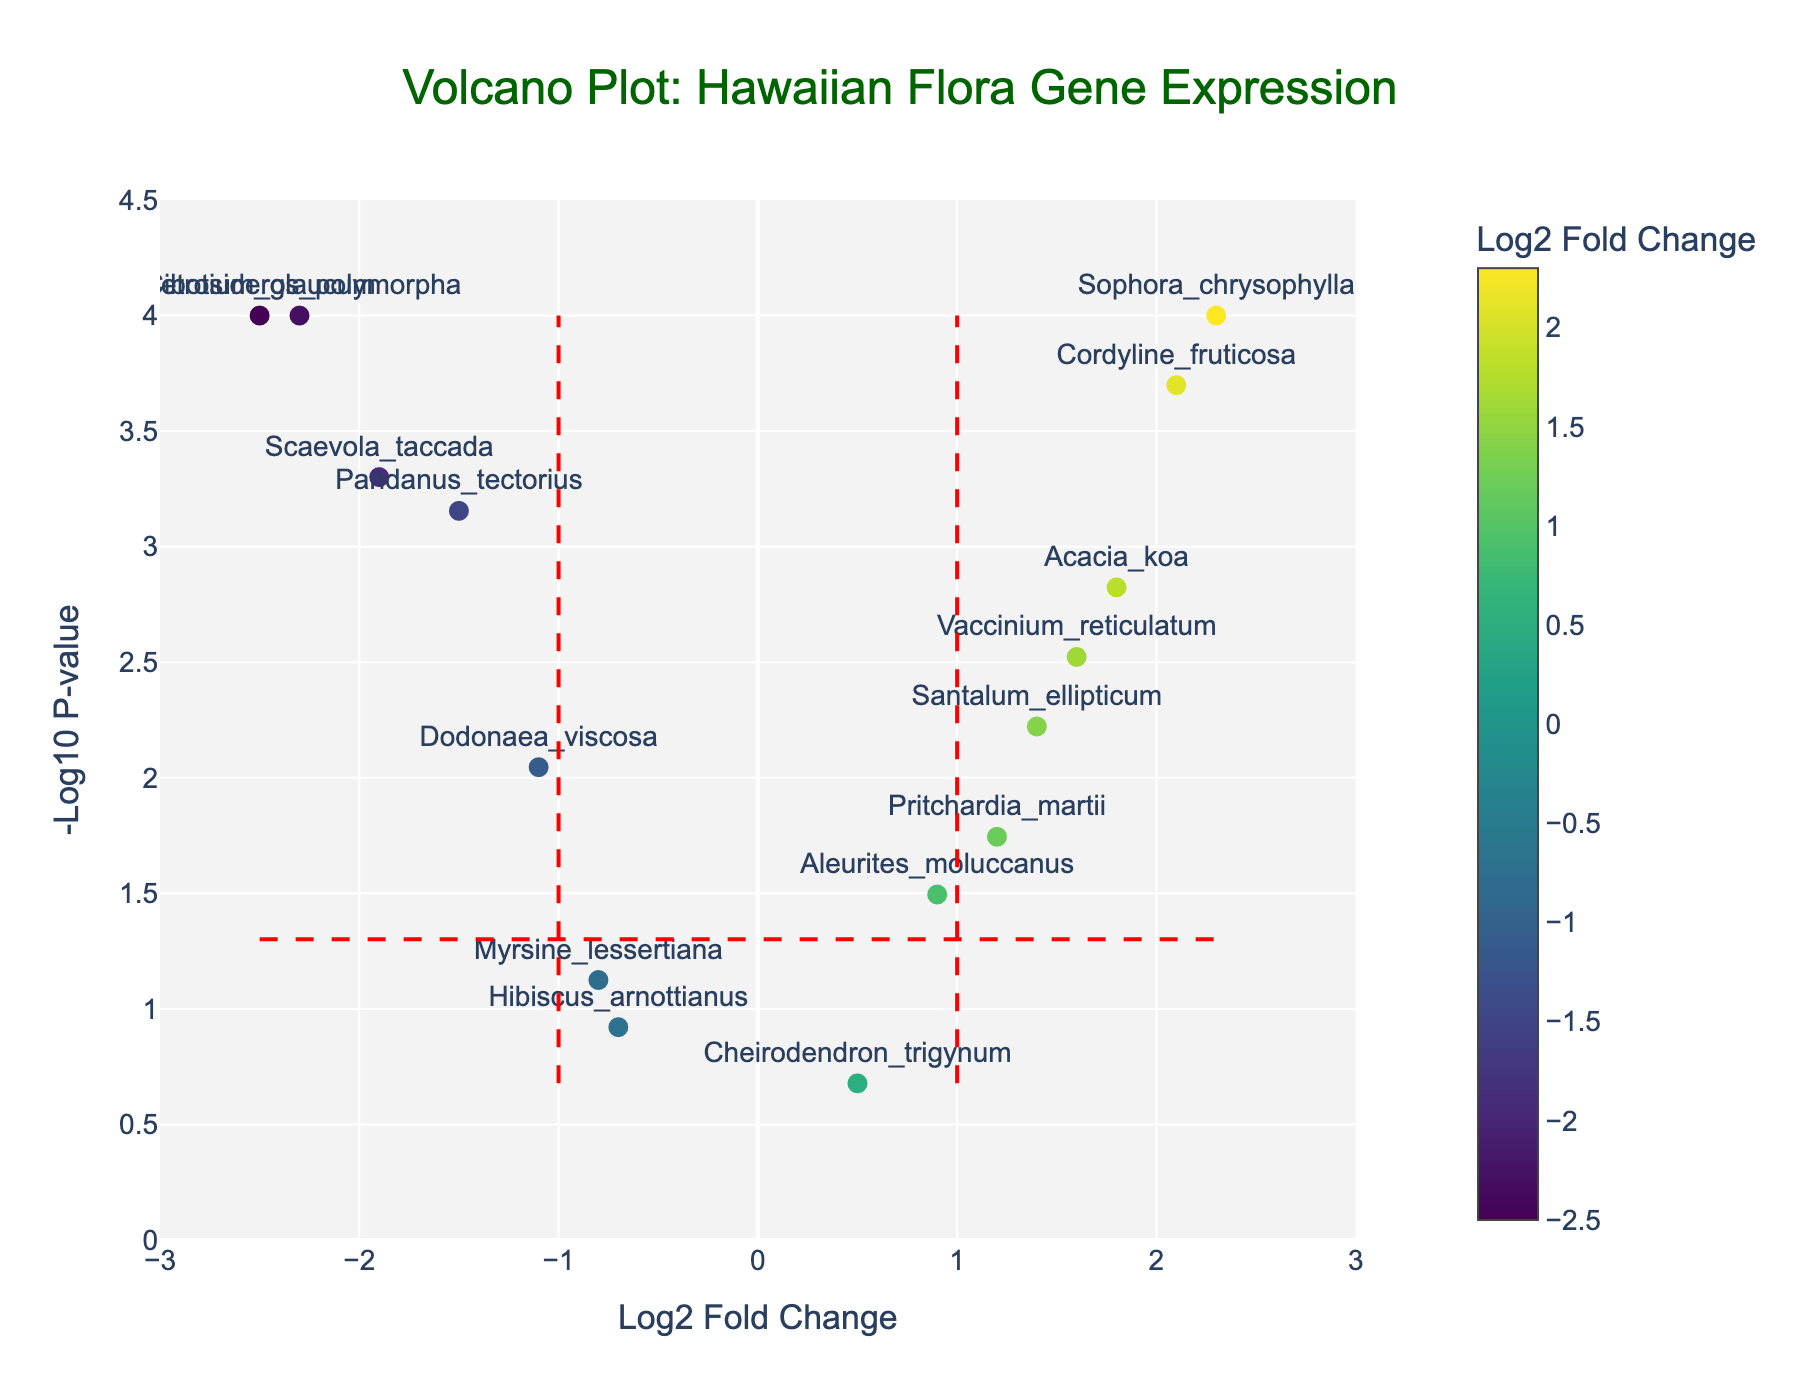What is the title of the plot? The title is prominently displayed at the top of the plot and reads "Volcano Plot: Hawaiian Flora Gene Expression".
Answer: Volcano Plot: Hawaiian Flora Gene Expression How is the Log2 Fold Change represented in the plot? Log2 Fold Change is represented on the x-axis, and the data points are colored on a gradient scale according to their Log2 Fold Change values.
Answer: On the x-axis and as colors How many genes have a p-value below 0.05? There is a horizontal red dashed line at -log10(p-value) of 0.05. Count the points above this line.
Answer: 12 genes Which gene has the highest Log2 Fold Change and what is its value? Look for the gene label positioned farthest to the right on the x-axis. This gene is "Sophora_chrysophylla" with a Log2 Fold Change of 2.3.
Answer: Sophora_chrysophylla, 2.3 Which gene is the most statistically significant and what is its p-value? The most statistically significant gene is the one with the highest -log10(p-value). This gene is "Metrosideros_polymorpha" with a p-value of 0.0001.
Answer: Metrosideros_polymorpha, 0.0001 What is the range of -log10 p-values in the dataset? Identify the minimum and maximum of the -log10(p-value) on the y-axis. The minimum is close to 0, and the maximum is around 4.
Answer: 0 to 4.5 How many genes are upregulated (Log2 Fold Change > 0 and p-value < 0.05)? Count the data points with positive x-values (Log2 Fold Change > 0) and are above the horizontal red dashed line (-log10 p-value of 0.05).
Answer: 6 genes Which genes fall within the nonsignificant range (p-value > 0.05)? These genes are below the dashed red horizontal line at -log10(p-value) of 0.05. Those are "Aleurites_moluccanus", "Hibiscus_arnottianus", "Cheirodendron_trigynum", and "Myrsine_lessertiana".
Answer: Aleurites_moluccanus, Hibiscus_arnottianus, Cheirodendron_trigynum, Myrsine_lessertiana Which genes are labeled in the bottom left quadrant of the plot? The bottom left quadrant includes genes with negative Log2 Fold Change and low -log10 p-values: "Hibiscus_arnottianus" and "Cheirodendron_trigynum".
Answer: Hibiscus_arnottianus, Cheirodendron_trigynum 